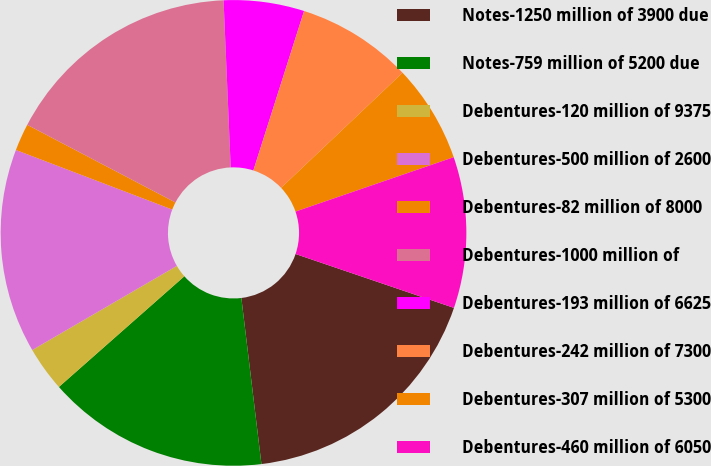Convert chart. <chart><loc_0><loc_0><loc_500><loc_500><pie_chart><fcel>Notes-1250 million of 3900 due<fcel>Notes-759 million of 5200 due<fcel>Debentures-120 million of 9375<fcel>Debentures-500 million of 2600<fcel>Debentures-82 million of 8000<fcel>Debentures-1000 million of<fcel>Debentures-193 million of 6625<fcel>Debentures-242 million of 7300<fcel>Debentures-307 million of 5300<fcel>Debentures-460 million of 6050<nl><fcel>17.87%<fcel>15.41%<fcel>3.12%<fcel>14.18%<fcel>1.89%<fcel>16.64%<fcel>5.58%<fcel>8.03%<fcel>6.8%<fcel>10.49%<nl></chart> 